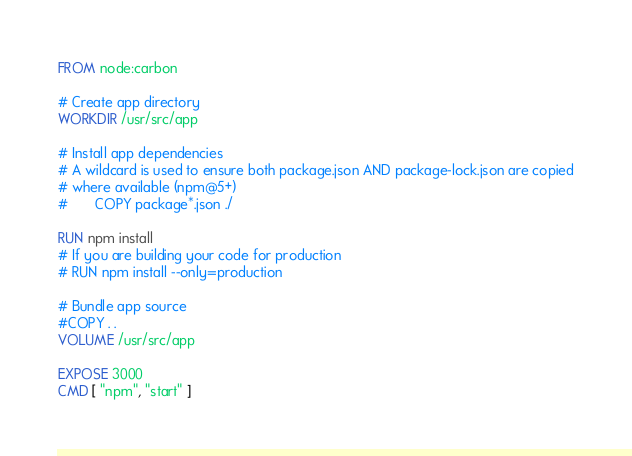<code> <loc_0><loc_0><loc_500><loc_500><_Dockerfile_>FROM node:carbon

# Create app directory
WORKDIR /usr/src/app

# Install app dependencies
# A wildcard is used to ensure both package.json AND package-lock.json are copied
# where available (npm@5+)
#       COPY package*.json ./

RUN npm install
# If you are building your code for production
# RUN npm install --only=production

# Bundle app source
#COPY . .
VOLUME /usr/src/app

EXPOSE 3000
CMD [ "npm", "start" ]
</code> 